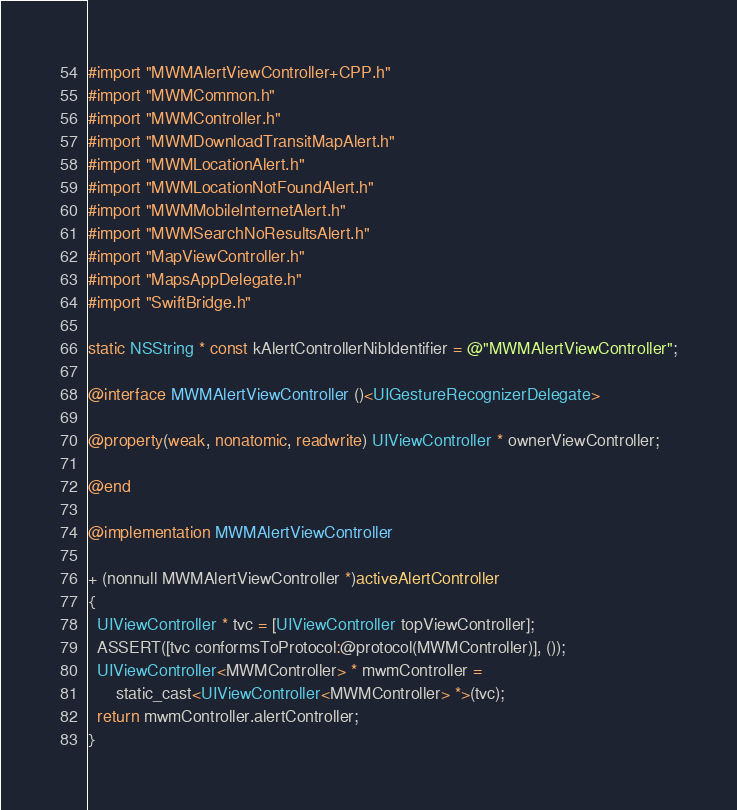Convert code to text. <code><loc_0><loc_0><loc_500><loc_500><_ObjectiveC_>#import "MWMAlertViewController+CPP.h"
#import "MWMCommon.h"
#import "MWMController.h"
#import "MWMDownloadTransitMapAlert.h"
#import "MWMLocationAlert.h"
#import "MWMLocationNotFoundAlert.h"
#import "MWMMobileInternetAlert.h"
#import "MWMSearchNoResultsAlert.h"
#import "MapViewController.h"
#import "MapsAppDelegate.h"
#import "SwiftBridge.h"

static NSString * const kAlertControllerNibIdentifier = @"MWMAlertViewController";

@interface MWMAlertViewController ()<UIGestureRecognizerDelegate>

@property(weak, nonatomic, readwrite) UIViewController * ownerViewController;

@end

@implementation MWMAlertViewController

+ (nonnull MWMAlertViewController *)activeAlertController
{
  UIViewController * tvc = [UIViewController topViewController];
  ASSERT([tvc conformsToProtocol:@protocol(MWMController)], ());
  UIViewController<MWMController> * mwmController =
      static_cast<UIViewController<MWMController> *>(tvc);
  return mwmController.alertController;
}
</code> 